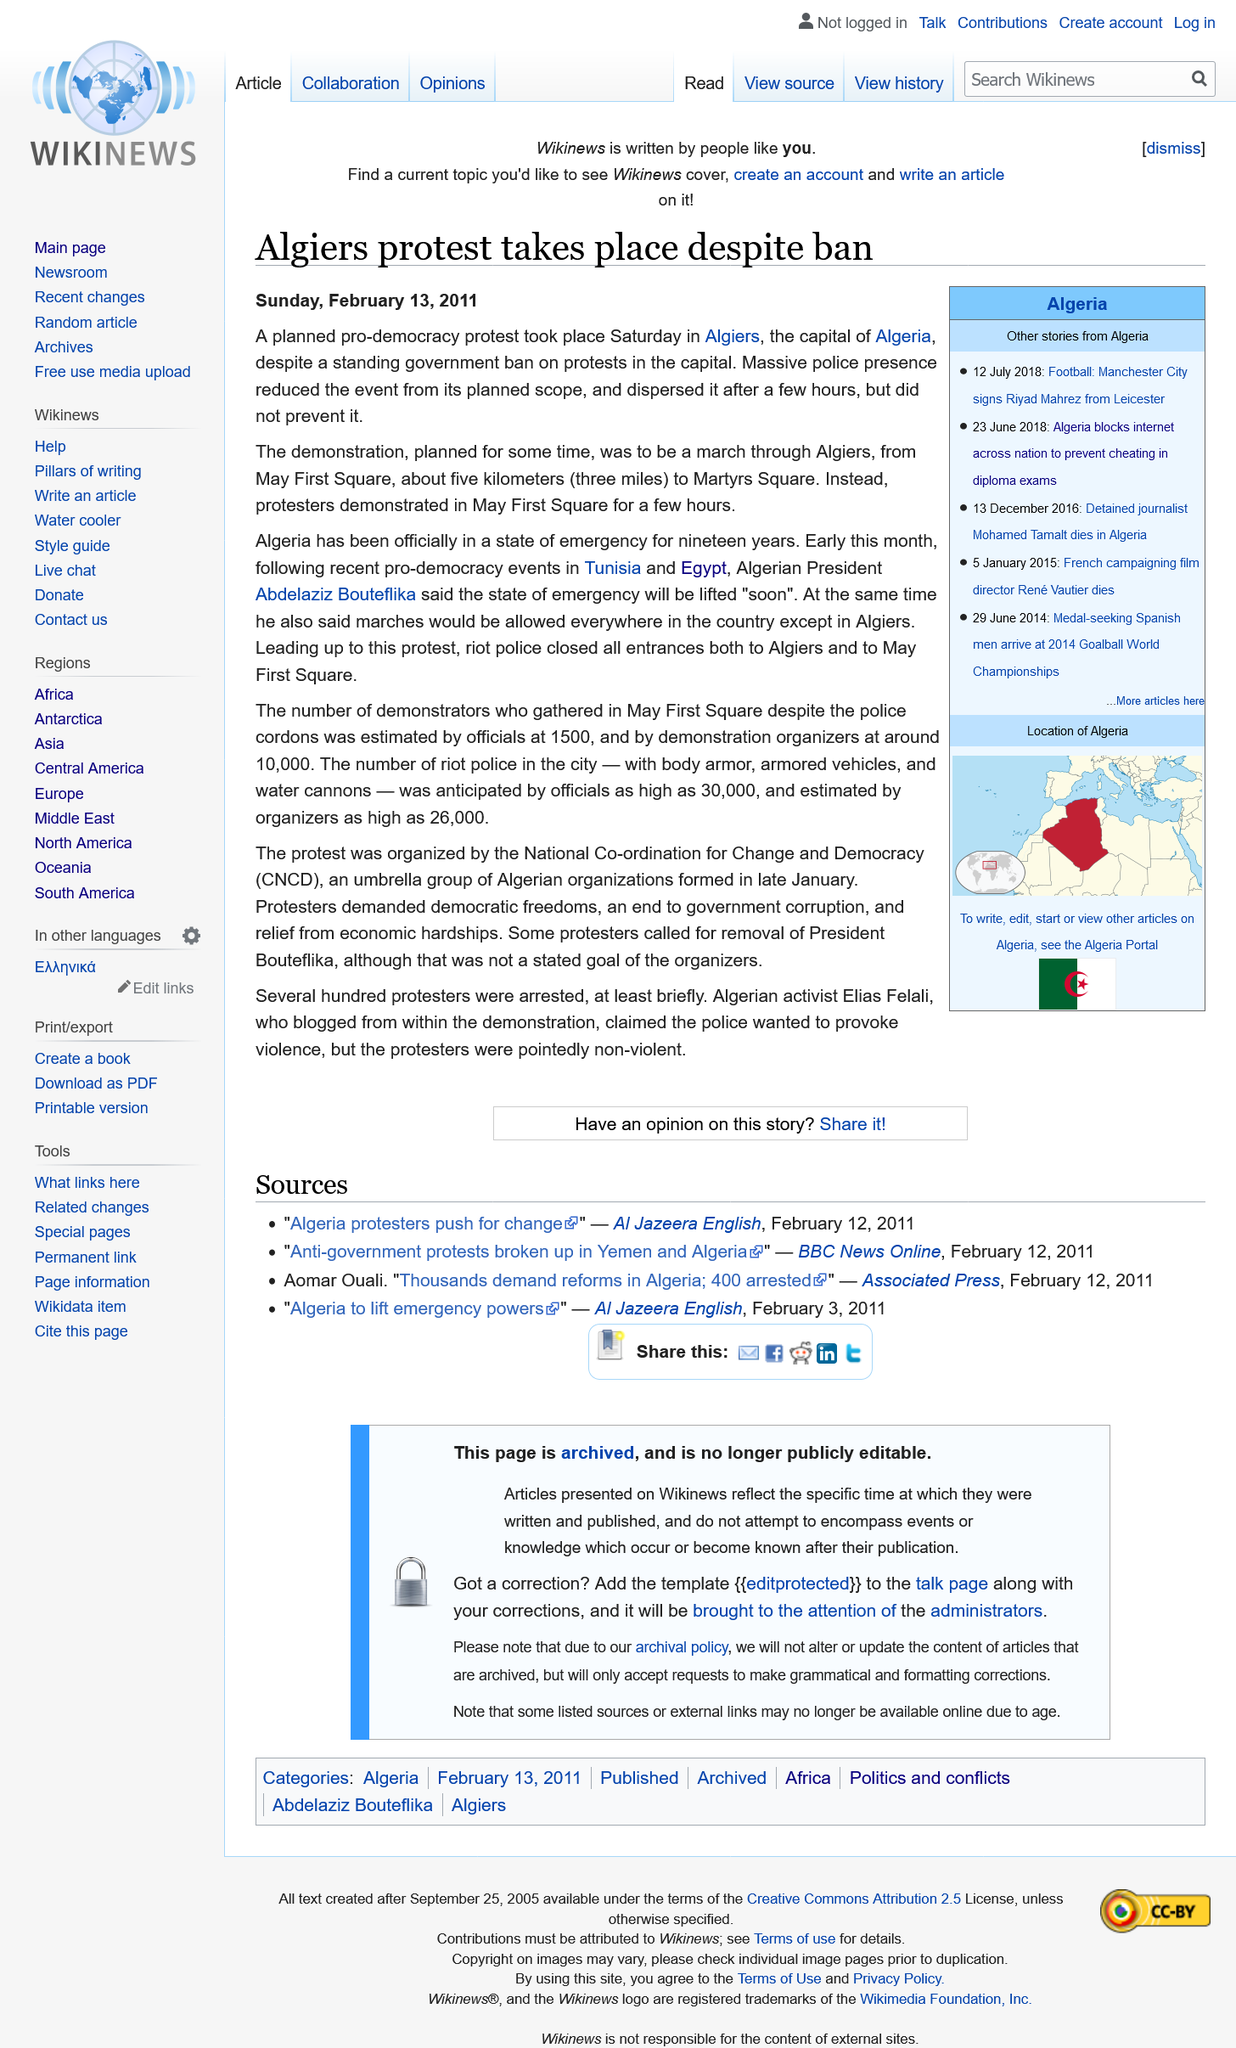List a handful of essential elements in this visual. On May First Square in Algiers, there was a protest that took place. The march did not happen to Martyrs Square, and it did not happen to the March to Martyrs Square. Algeria has been under a state of emergency for 19 years. 